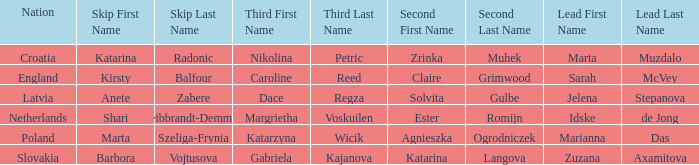Which Lead has Katarina Radonic as Skip? Marta Muzdalo. 